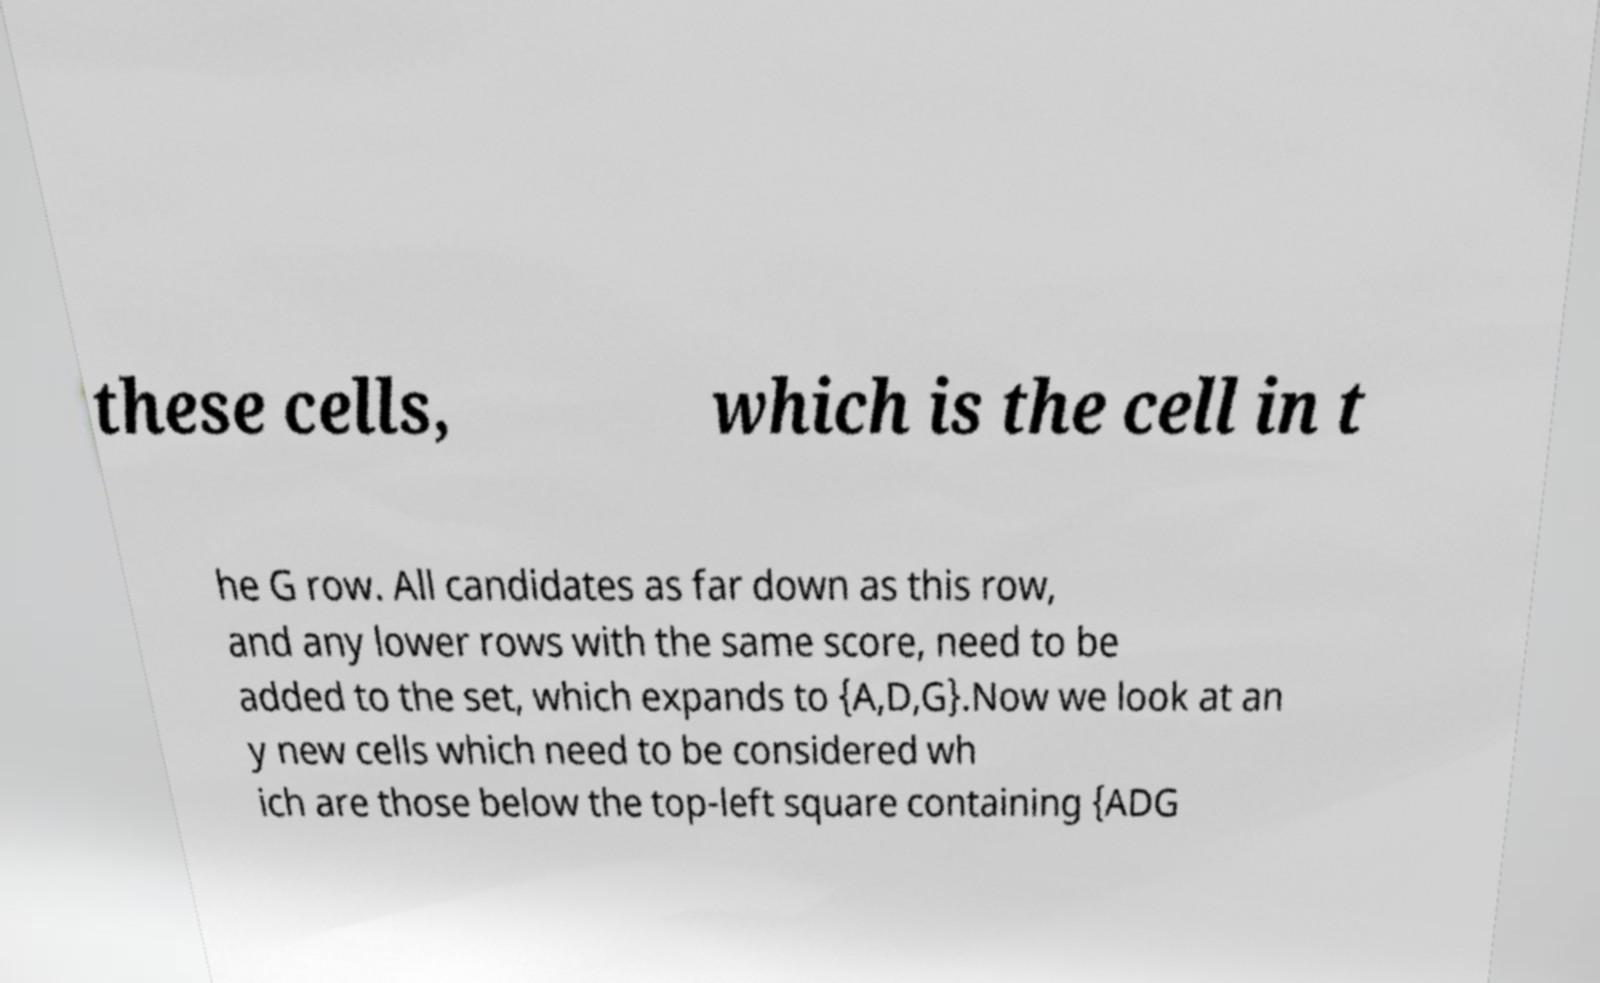What messages or text are displayed in this image? I need them in a readable, typed format. these cells, which is the cell in t he G row. All candidates as far down as this row, and any lower rows with the same score, need to be added to the set, which expands to {A,D,G}.Now we look at an y new cells which need to be considered wh ich are those below the top-left square containing {ADG 